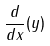<formula> <loc_0><loc_0><loc_500><loc_500>\frac { d } { d x } ( y )</formula> 